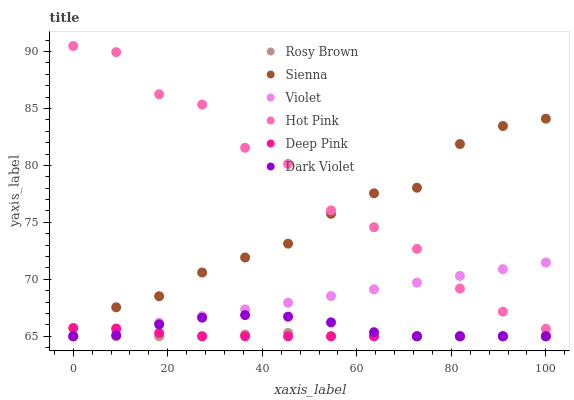Does Rosy Brown have the minimum area under the curve?
Answer yes or no. Yes. Does Hot Pink have the maximum area under the curve?
Answer yes or no. Yes. Does Dark Violet have the minimum area under the curve?
Answer yes or no. No. Does Dark Violet have the maximum area under the curve?
Answer yes or no. No. Is Violet the smoothest?
Answer yes or no. Yes. Is Hot Pink the roughest?
Answer yes or no. Yes. Is Dark Violet the smoothest?
Answer yes or no. No. Is Dark Violet the roughest?
Answer yes or no. No. Does Rosy Brown have the lowest value?
Answer yes or no. Yes. Does Hot Pink have the lowest value?
Answer yes or no. No. Does Hot Pink have the highest value?
Answer yes or no. Yes. Does Dark Violet have the highest value?
Answer yes or no. No. Is Rosy Brown less than Hot Pink?
Answer yes or no. Yes. Is Hot Pink greater than Rosy Brown?
Answer yes or no. Yes. Does Sienna intersect Dark Violet?
Answer yes or no. Yes. Is Sienna less than Dark Violet?
Answer yes or no. No. Is Sienna greater than Dark Violet?
Answer yes or no. No. Does Rosy Brown intersect Hot Pink?
Answer yes or no. No. 